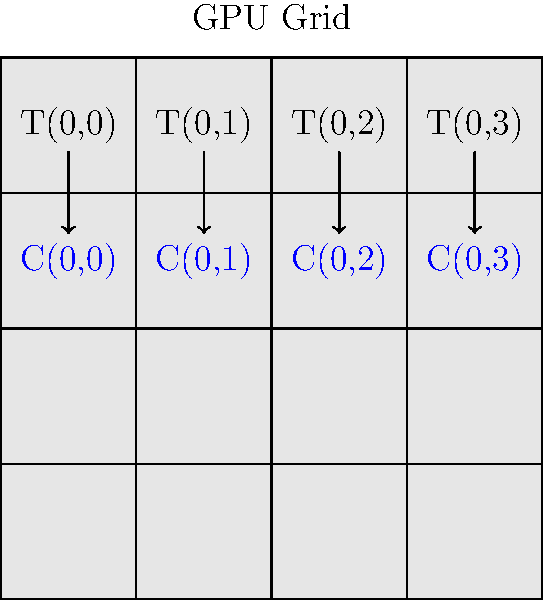In the context of matrix multiplication on a GPU, consider a scenario where matrix A (4x4) is multiplied by matrix B (4x4) to produce matrix C (4x4). Given the thread block configuration shown in the diagram, where each thread block is responsible for computing one element of the result matrix C, what is the total number of thread blocks required to compute the entire matrix C? Additionally, how many threads per block would be optimal if we want to utilize shared memory for coalesced memory access? To answer this question, let's break it down step by step:

1. Matrix dimensions:
   - Matrix A: 4x4
   - Matrix B: 4x4
   - Result matrix C: 4x4

2. Thread block configuration:
   - Each thread block computes one element of matrix C
   - The diagram shows a 4x4 grid of thread blocks

3. Number of thread blocks required:
   - Total elements in matrix C = 4 * 4 = 16
   - Each thread block computes one element
   - Therefore, the total number of thread blocks required = 16

4. Optimal number of threads per block:
   - For matrix multiplication, it's common to use a 2D block configuration
   - A typical choice is 16x16 or 32x32 threads per block
   - 16x16 = 256 threads per block
   - 32x32 = 1024 threads per block
   - The optimal choice depends on the GPU architecture and shared memory size
   - For this 4x4 matrix, a 16x16 configuration would be sufficient and efficient

5. Utilizing shared memory for coalesced memory access:
   - Shared memory is fast on-chip memory shared by all threads in a block
   - To maximize coalesced memory access, we want adjacent threads to access adjacent memory locations
   - A 16x16 thread block can efficiently load a 16x16 tile of the input matrices into shared memory
   - This configuration allows for coalesced global memory access and efficient use of shared memory

Therefore, the optimal configuration would be:
- Total number of thread blocks: 16
- Threads per block: 16x16 = 256
Answer: 16 thread blocks, 256 threads per block (16x16) 